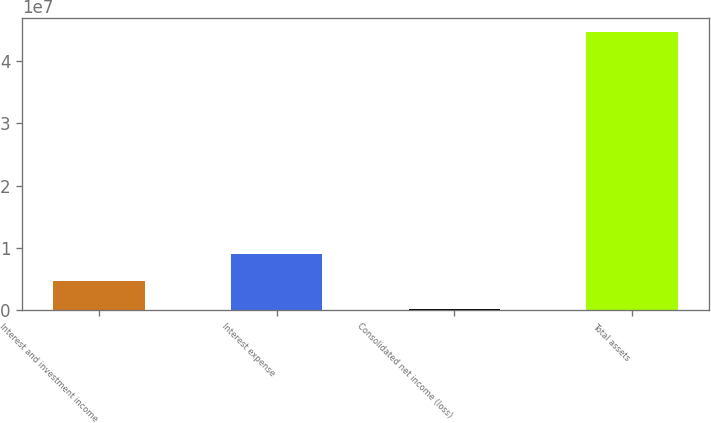Convert chart. <chart><loc_0><loc_0><loc_500><loc_500><bar_chart><fcel>Interest and investment income<fcel>Interest expense<fcel>Consolidated net income (loss)<fcel>Total assets<nl><fcel>4.60583e+06<fcel>9.05492e+06<fcel>156734<fcel>4.46477e+07<nl></chart> 